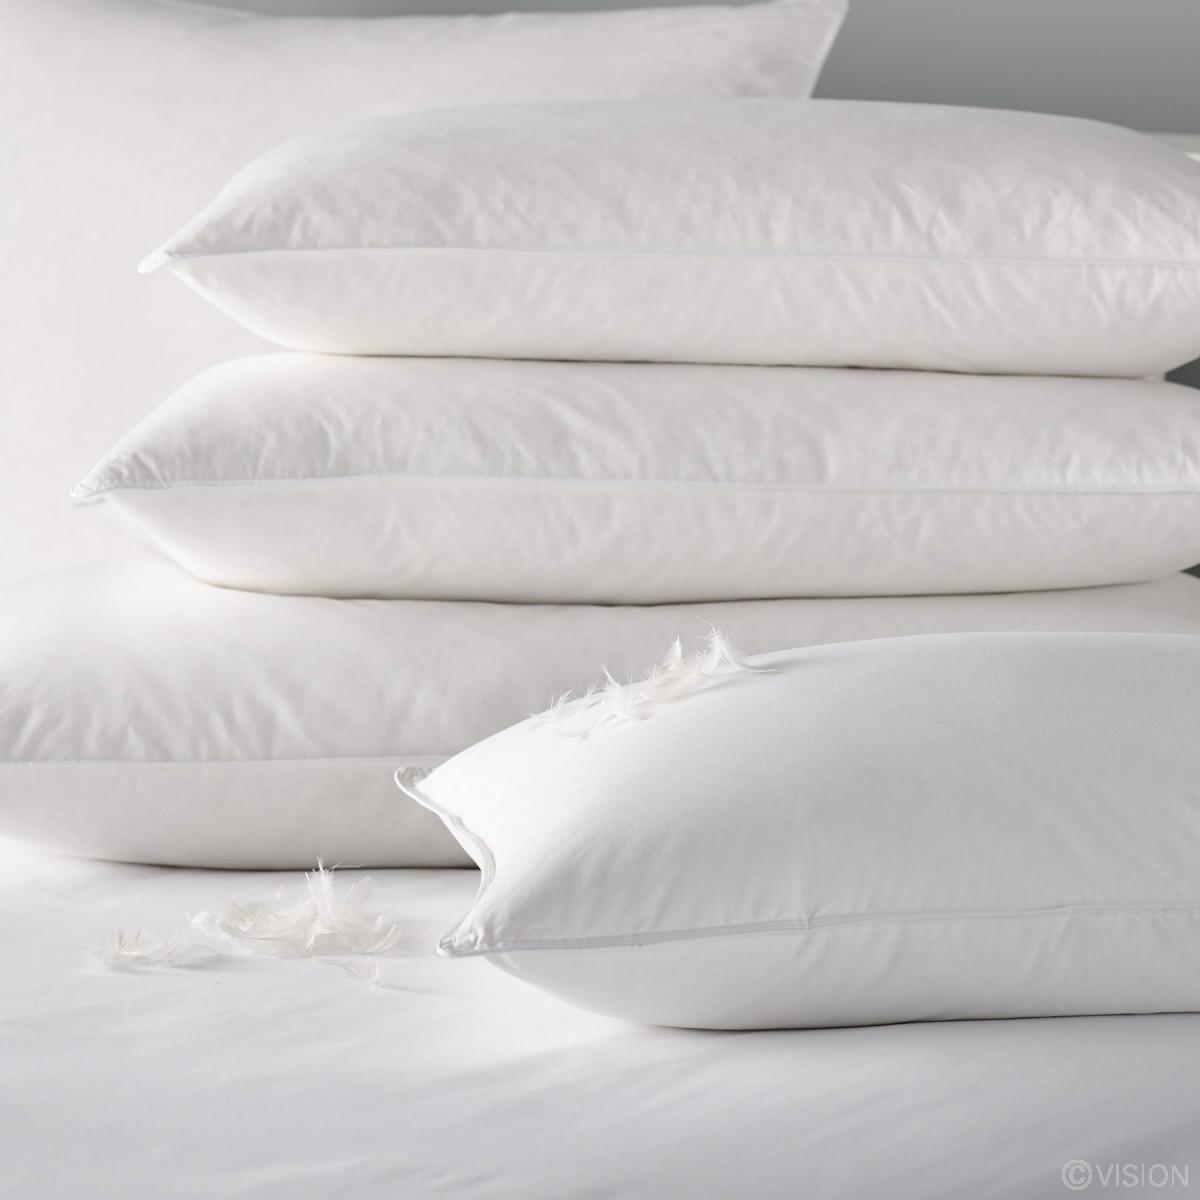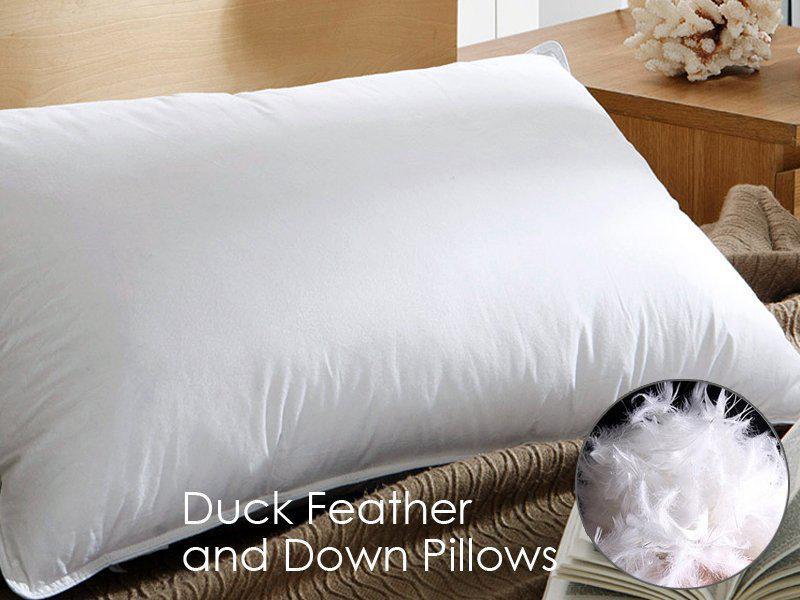The first image is the image on the left, the second image is the image on the right. Analyze the images presented: Is the assertion "Two pillows are stacked on each other in the image on the right." valid? Answer yes or no. No. The first image is the image on the left, the second image is the image on the right. Assess this claim about the two images: "An image with exactly two white pillows includes at least one white feather at the bottom right.". Correct or not? Answer yes or no. No. 